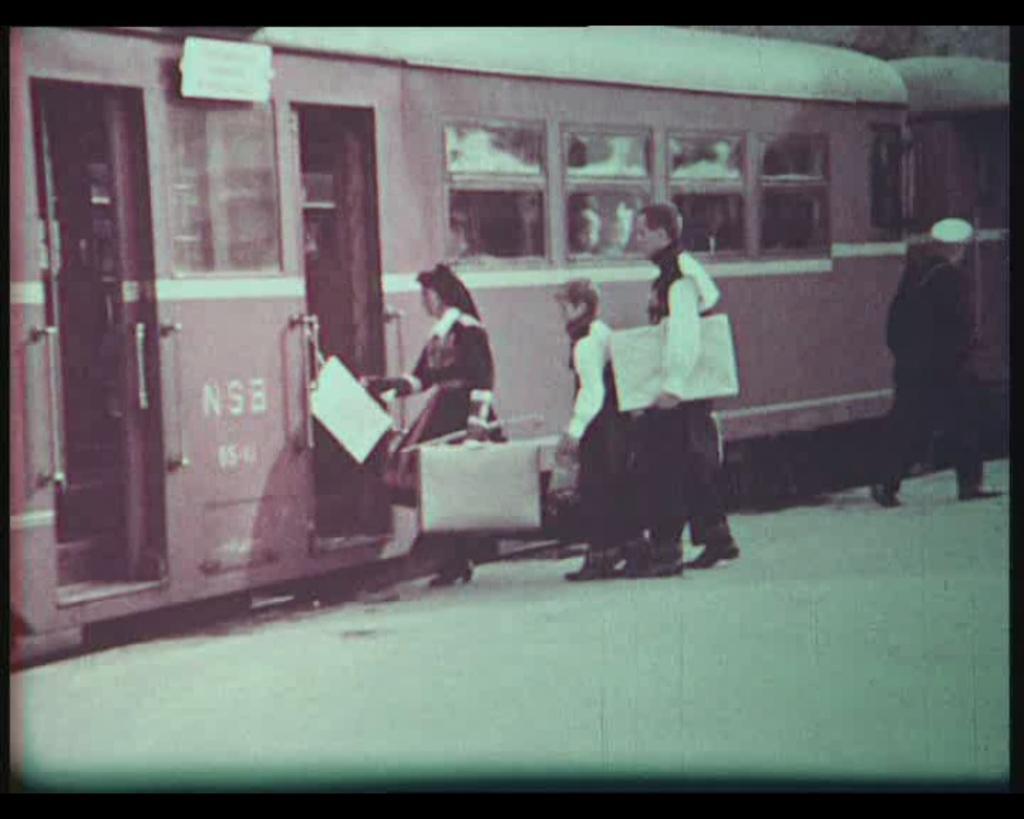How would you summarize this image in a sentence or two? In the picture I can see people are standing on the ground, among them some are holding objects in hands. In the background I can see a train. 